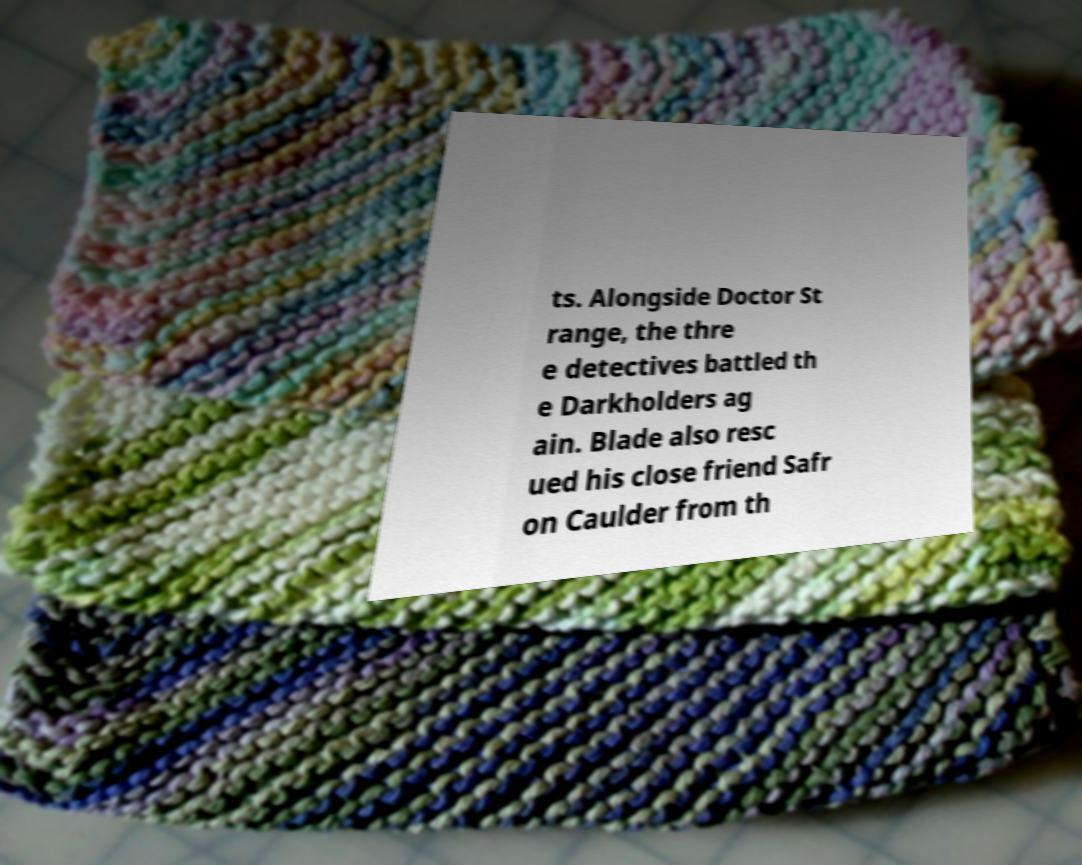Please identify and transcribe the text found in this image. ts. Alongside Doctor St range, the thre e detectives battled th e Darkholders ag ain. Blade also resc ued his close friend Safr on Caulder from th 